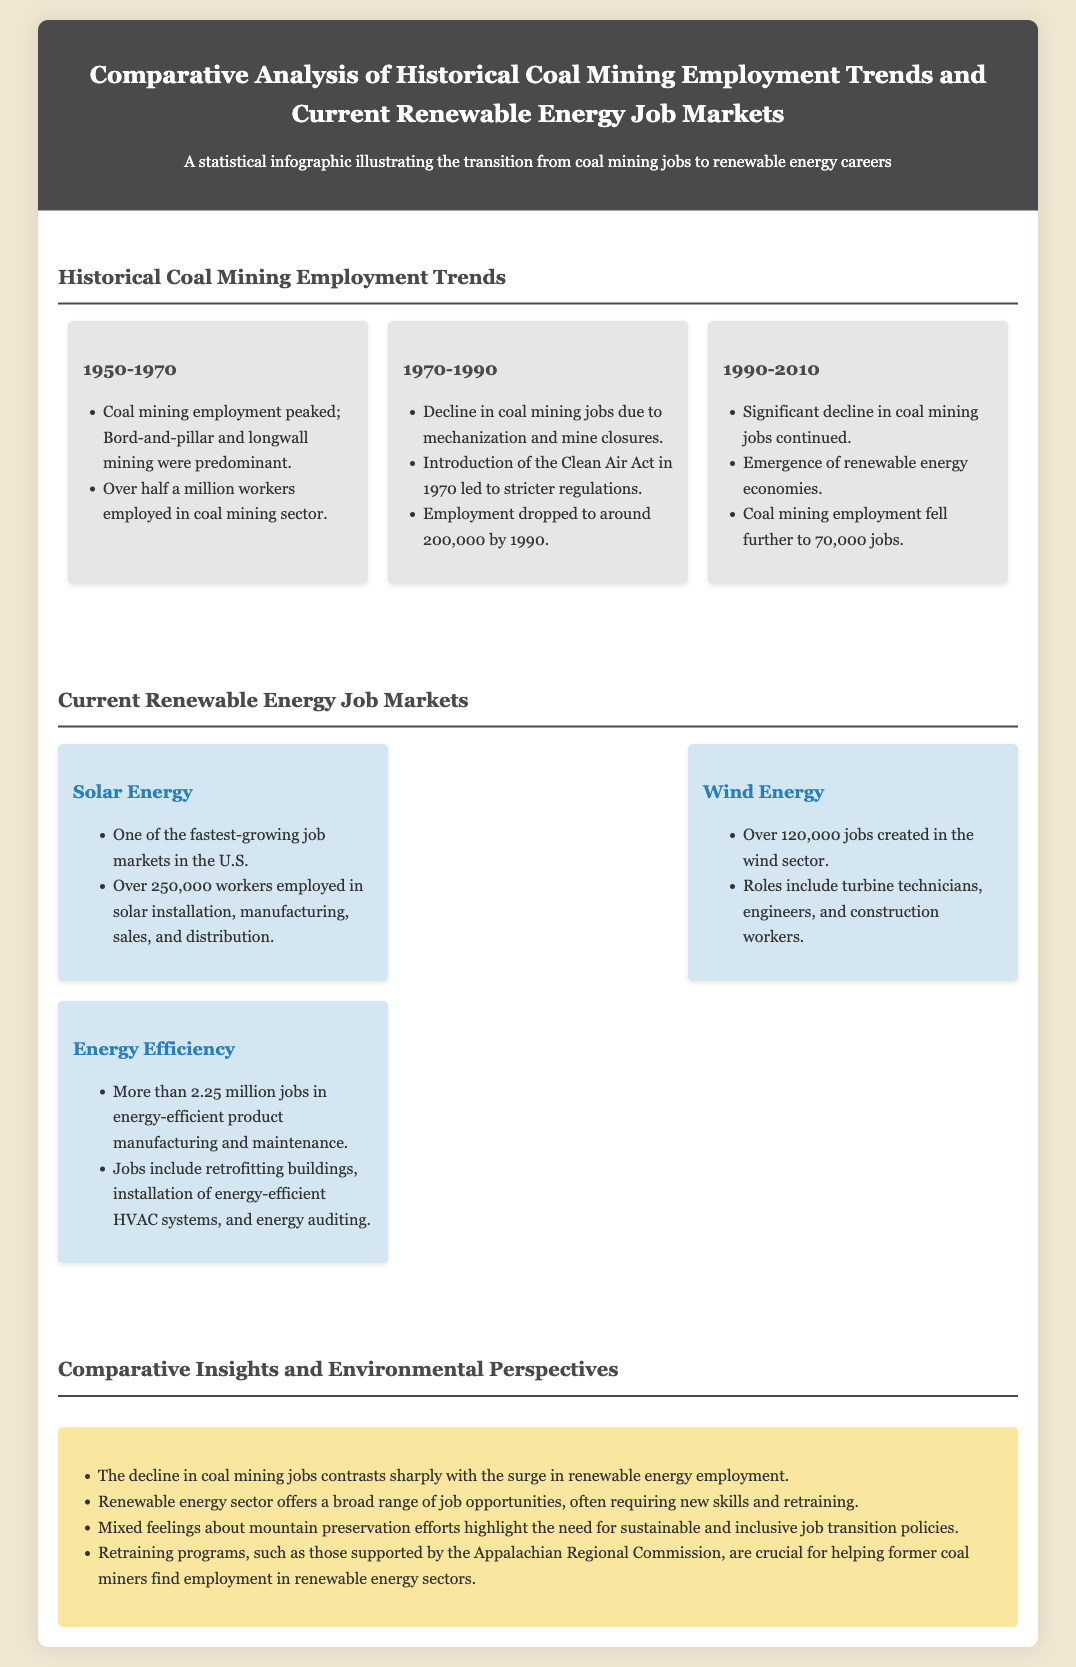What was the peak employment in coal mining? The document states that coal mining employment peaked at over half a million workers during the 1950-1970 period.
Answer: over half a million What year did coal mining employment drop to around 200,000? According to the infographic, coal mining employment dropped to around 200,000 by 1990.
Answer: 1990 How many jobs were created in the wind sector? The document mentions that over 120,000 jobs were created in the wind sector.
Answer: over 120,000 What is one role in the wind energy job market? The infographic lists turbine technicians, engineers, and construction workers as roles in the wind energy market.
Answer: turbine technicians Which renewable energy sector has the highest employment? The section on current renewable energy job markets indicates that the energy efficiency sector has more than 2.25 million jobs.
Answer: energy efficiency What program supports retraining for former coal miners? The document highlights retraining programs supported by the Appalachian Regional Commission.
Answer: Appalachian Regional Commission What contrasting trend is observed in the document? The document states that the decline in coal mining jobs contrasts sharply with the surge in renewable energy employment.
Answer: decline in coal mining jobs What is highlighted about the need for job transitions? The document emphasizes the need for sustainable and inclusive job transition policies following coal mining declines.
Answer: sustainable and inclusive job transition policies 